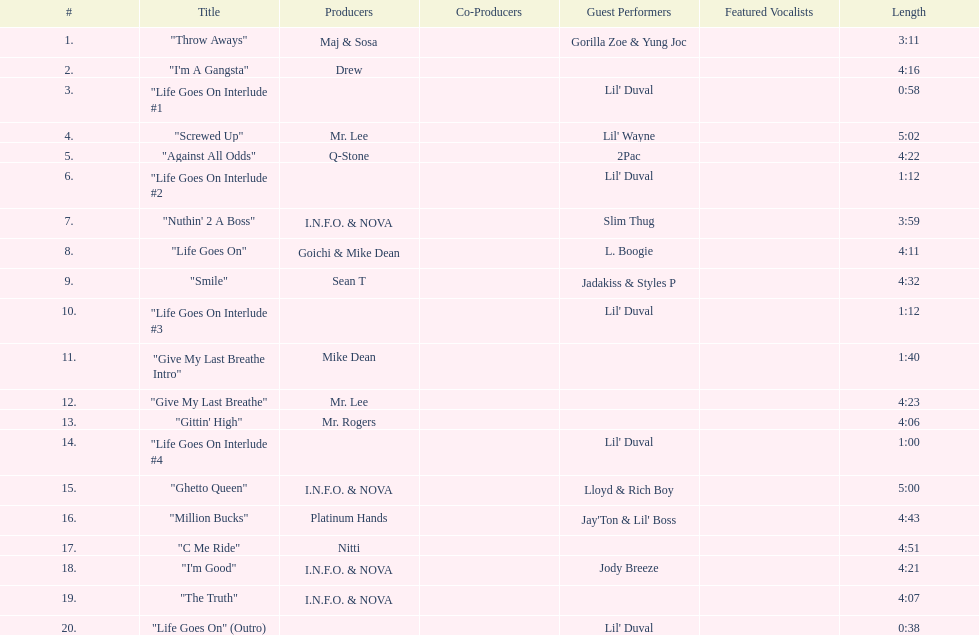What is the first track featuring lil' duval? "Life Goes On Interlude #1. 